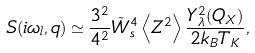Convert formula to latex. <formula><loc_0><loc_0><loc_500><loc_500>S ( i \omega _ { l } , { q } ) \simeq \frac { 3 ^ { 2 } } { 4 ^ { 2 } } \tilde { W } _ { s } ^ { 4 } \left < Z ^ { 2 } \right > \frac { Y _ { \lambda } ^ { 2 } ( { Q } _ { X } ) } { 2 k _ { B } T _ { K } } ,</formula> 